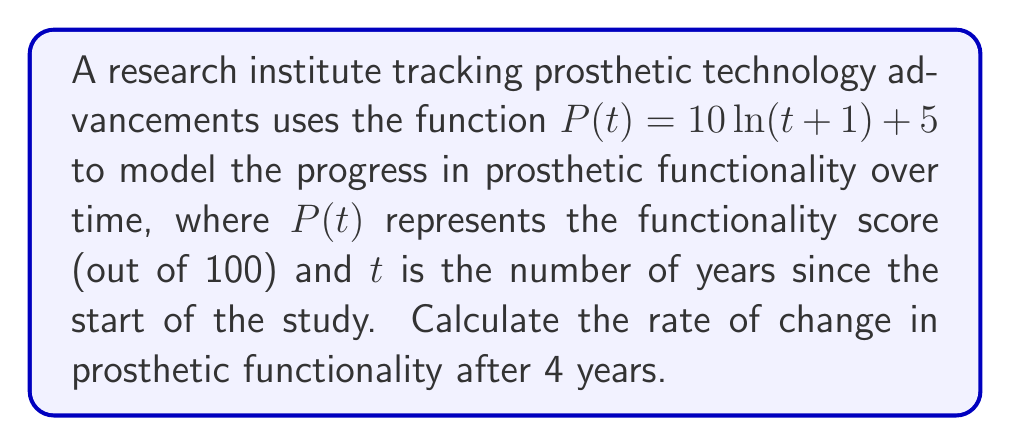Solve this math problem. To find the rate of change in prosthetic functionality after 4 years, we need to calculate the derivative of $P(t)$ and evaluate it at $t=4$.

Step 1: Find the derivative of $P(t)$
$$P(t) = 10\ln(t+1) + 5$$
$$P'(t) = 10 \cdot \frac{d}{dt}[\ln(t+1)] + \frac{d}{dt}[5]$$
$$P'(t) = 10 \cdot \frac{1}{t+1} + 0$$
$$P'(t) = \frac{10}{t+1}$$

Step 2: Evaluate $P'(t)$ at $t=4$
$$P'(4) = \frac{10}{4+1} = \frac{10}{5} = 2$$

Therefore, the rate of change in prosthetic functionality after 4 years is 2 units per year.
Answer: $2$ units per year 